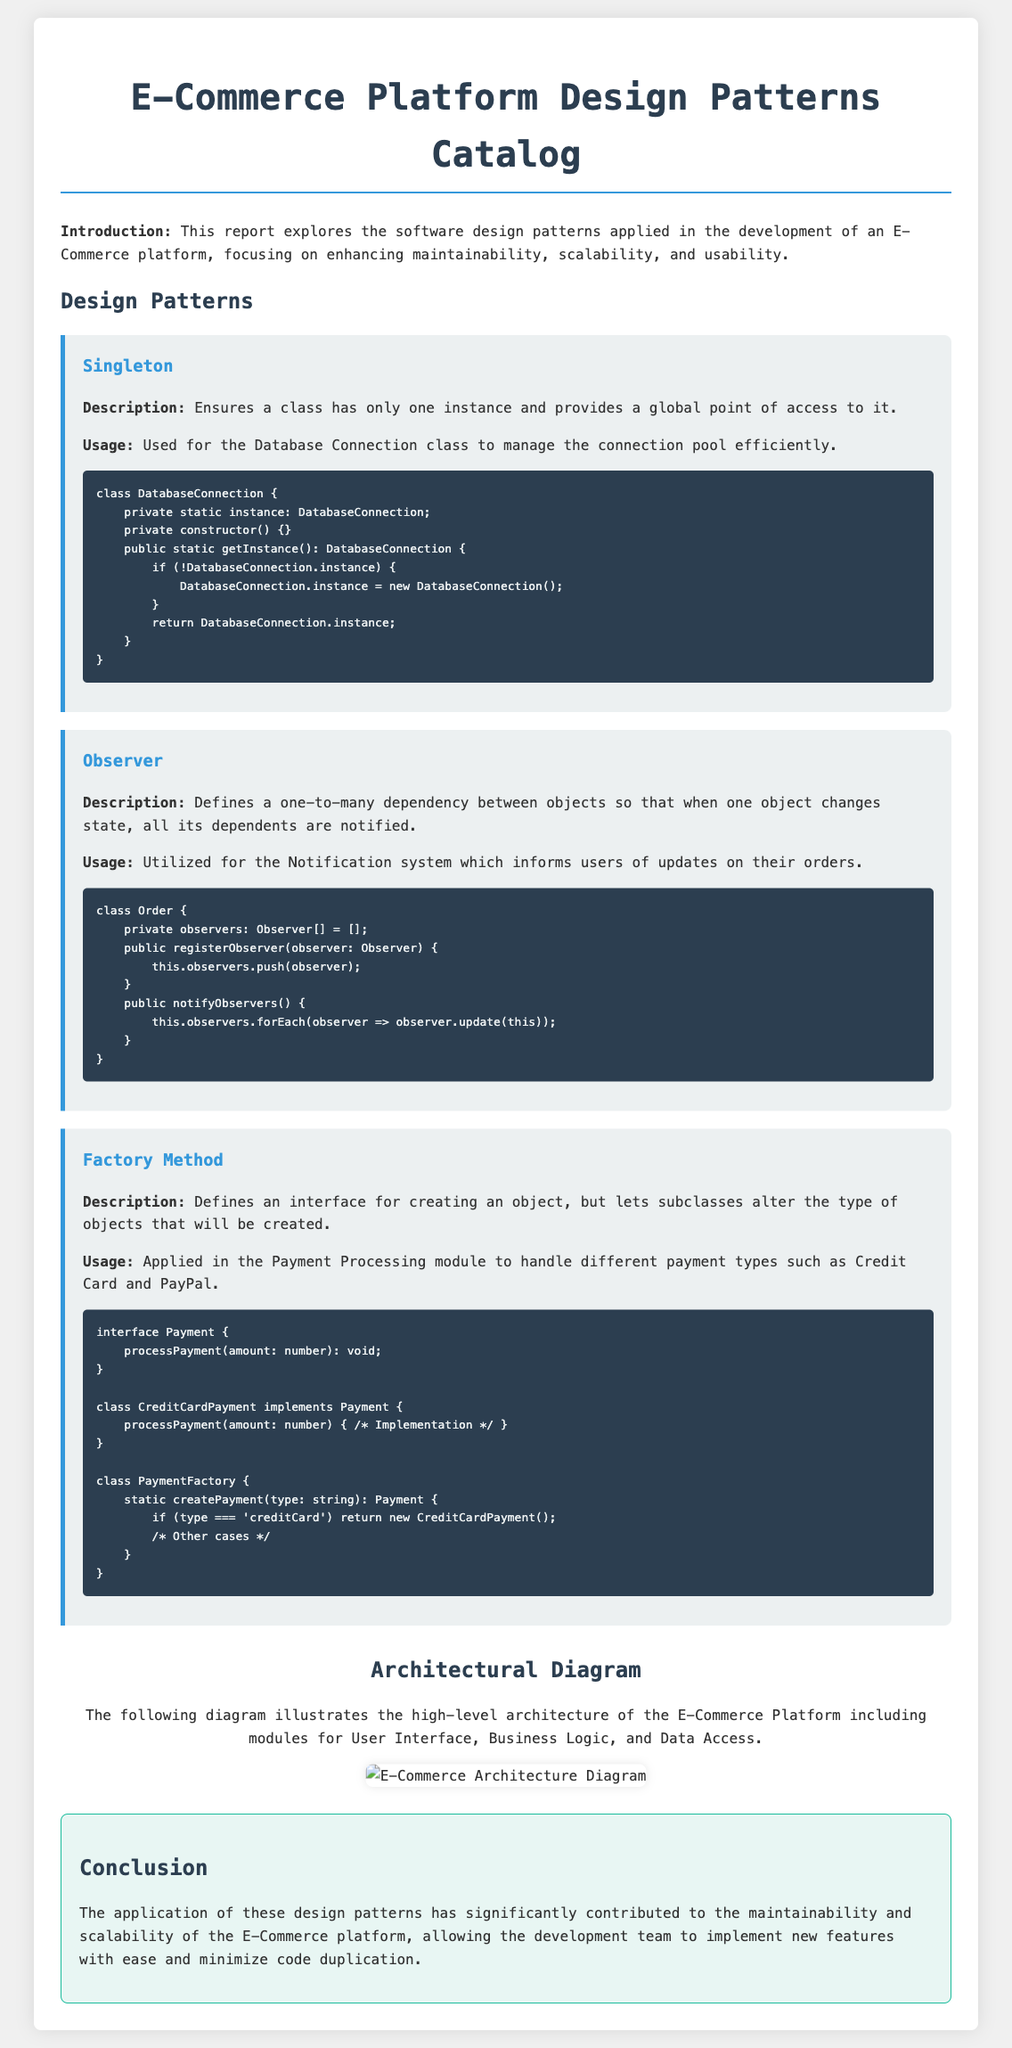What is the title of the document? The title of the document is stated in the document's heading as "E-Commerce Platform Design Patterns Catalog."
Answer: E-Commerce Platform Design Patterns Catalog What design pattern is described for database management? The document specifies that the Singleton design pattern is used for managing the database connection.
Answer: Singleton What type of design pattern is used for notifying users of order updates? The Observer design pattern is utilized for the notification system in the document.
Answer: Observer Which design pattern is applied to handle different payment types? The Factory Method pattern is applied in the payment processing module according to the document.
Answer: Factory Method What architectural aspect does the diagram illustrate? The diagram illustrates the high-level architecture of the E-Commerce Platform including modules for User Interface, Business Logic, and Data Access.
Answer: High-level architecture How does the conclusion describe the impact of design patterns? The conclusion indicates that the application of design patterns has significantly contributed to the maintainability and scalability of the E-Commerce platform.
Answer: Maintainability and scalability What method is used to register observers in the Order class? The method to register observers in the Order class is called "registerObserver."
Answer: registerObserver What is the purpose of the PaymentFactory class? The PaymentFactory class's purpose is to create payment types.
Answer: Create payment types 